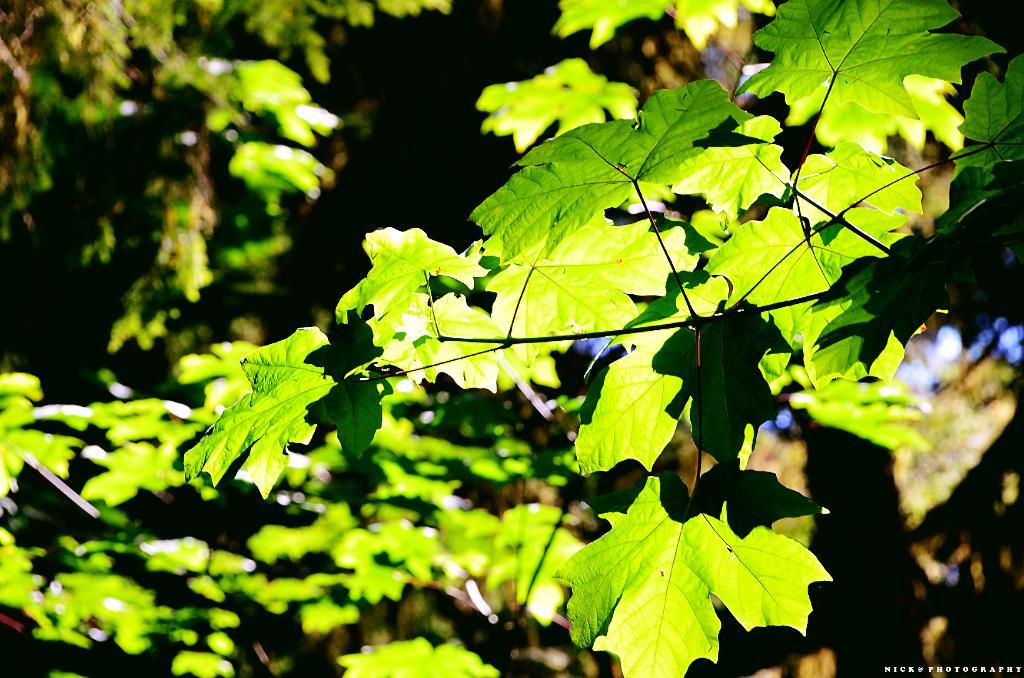What type of natural elements can be seen in the image? There are trees in the image. What is written or depicted at the bottom of the image? There is text at the bottom of the image. How would you describe the overall color scheme of the image? The background of the image is dark. Can you tell me how many plates are stacked on the rod in the image? There are no plates or rods present in the image. 